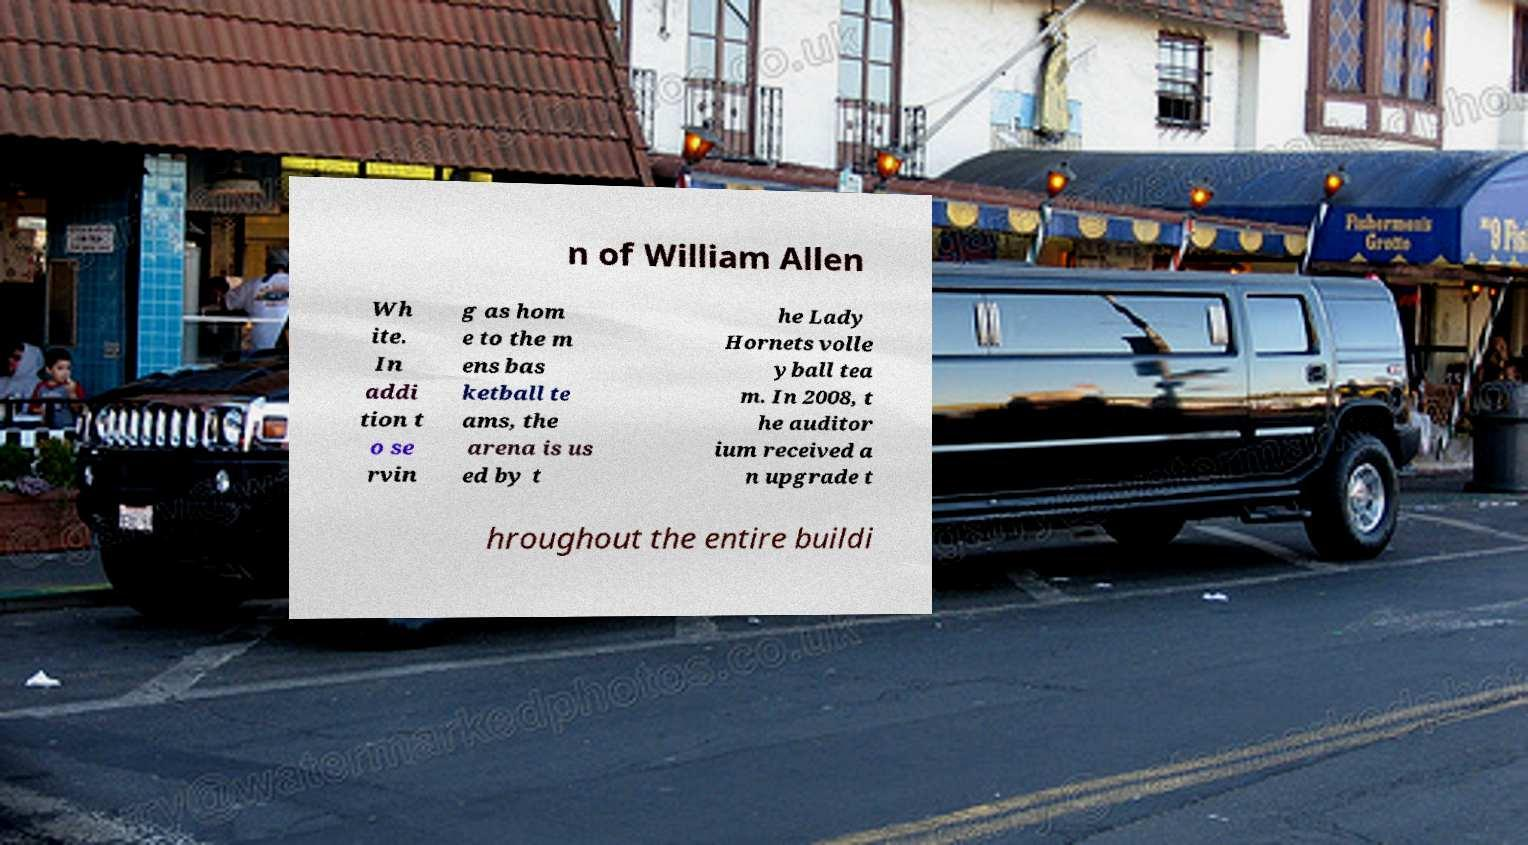Can you accurately transcribe the text from the provided image for me? n of William Allen Wh ite. In addi tion t o se rvin g as hom e to the m ens bas ketball te ams, the arena is us ed by t he Lady Hornets volle yball tea m. In 2008, t he auditor ium received a n upgrade t hroughout the entire buildi 